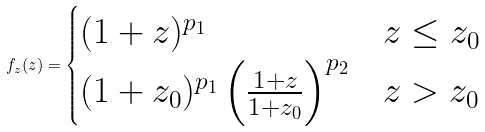<formula> <loc_0><loc_0><loc_500><loc_500>f _ { z } ( z ) = \begin{cases} ( 1 + z ) ^ { p _ { 1 } } & z \leq z _ { 0 } \\ ( 1 + z _ { 0 } ) ^ { p _ { 1 } } \left ( \frac { 1 + z } { 1 + z _ { 0 } } \right ) ^ { p _ { 2 } } & z > z _ { 0 } \\ \end{cases}</formula> 